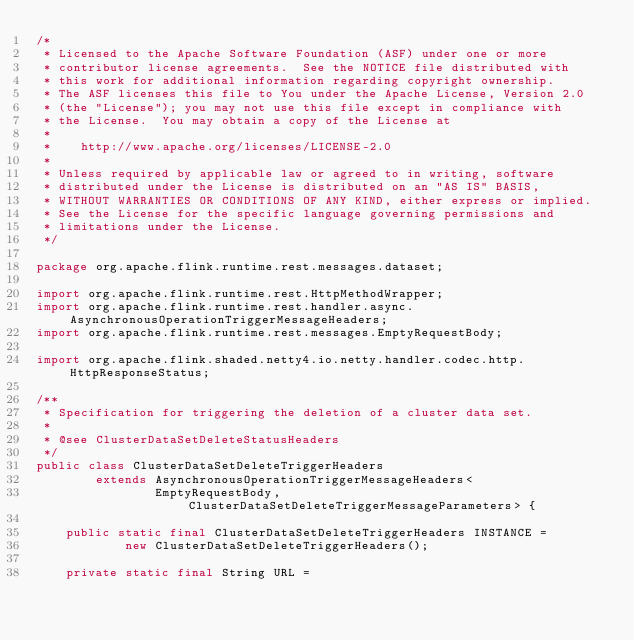Convert code to text. <code><loc_0><loc_0><loc_500><loc_500><_Java_>/*
 * Licensed to the Apache Software Foundation (ASF) under one or more
 * contributor license agreements.  See the NOTICE file distributed with
 * this work for additional information regarding copyright ownership.
 * The ASF licenses this file to You under the Apache License, Version 2.0
 * (the "License"); you may not use this file except in compliance with
 * the License.  You may obtain a copy of the License at
 *
 *    http://www.apache.org/licenses/LICENSE-2.0
 *
 * Unless required by applicable law or agreed to in writing, software
 * distributed under the License is distributed on an "AS IS" BASIS,
 * WITHOUT WARRANTIES OR CONDITIONS OF ANY KIND, either express or implied.
 * See the License for the specific language governing permissions and
 * limitations under the License.
 */

package org.apache.flink.runtime.rest.messages.dataset;

import org.apache.flink.runtime.rest.HttpMethodWrapper;
import org.apache.flink.runtime.rest.handler.async.AsynchronousOperationTriggerMessageHeaders;
import org.apache.flink.runtime.rest.messages.EmptyRequestBody;

import org.apache.flink.shaded.netty4.io.netty.handler.codec.http.HttpResponseStatus;

/**
 * Specification for triggering the deletion of a cluster data set.
 *
 * @see ClusterDataSetDeleteStatusHeaders
 */
public class ClusterDataSetDeleteTriggerHeaders
        extends AsynchronousOperationTriggerMessageHeaders<
                EmptyRequestBody, ClusterDataSetDeleteTriggerMessageParameters> {

    public static final ClusterDataSetDeleteTriggerHeaders INSTANCE =
            new ClusterDataSetDeleteTriggerHeaders();

    private static final String URL =</code> 